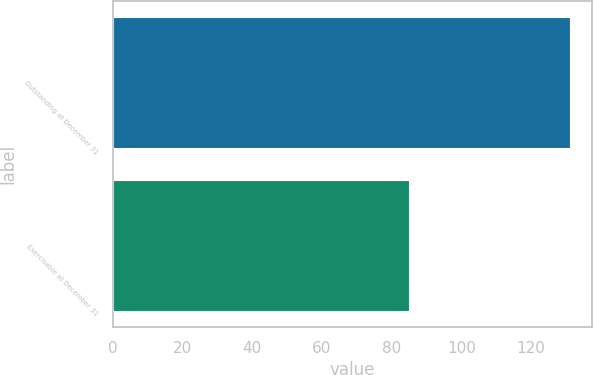Convert chart to OTSL. <chart><loc_0><loc_0><loc_500><loc_500><bar_chart><fcel>Outstanding at December 31<fcel>Exercisable at December 31<nl><fcel>131<fcel>85<nl></chart> 